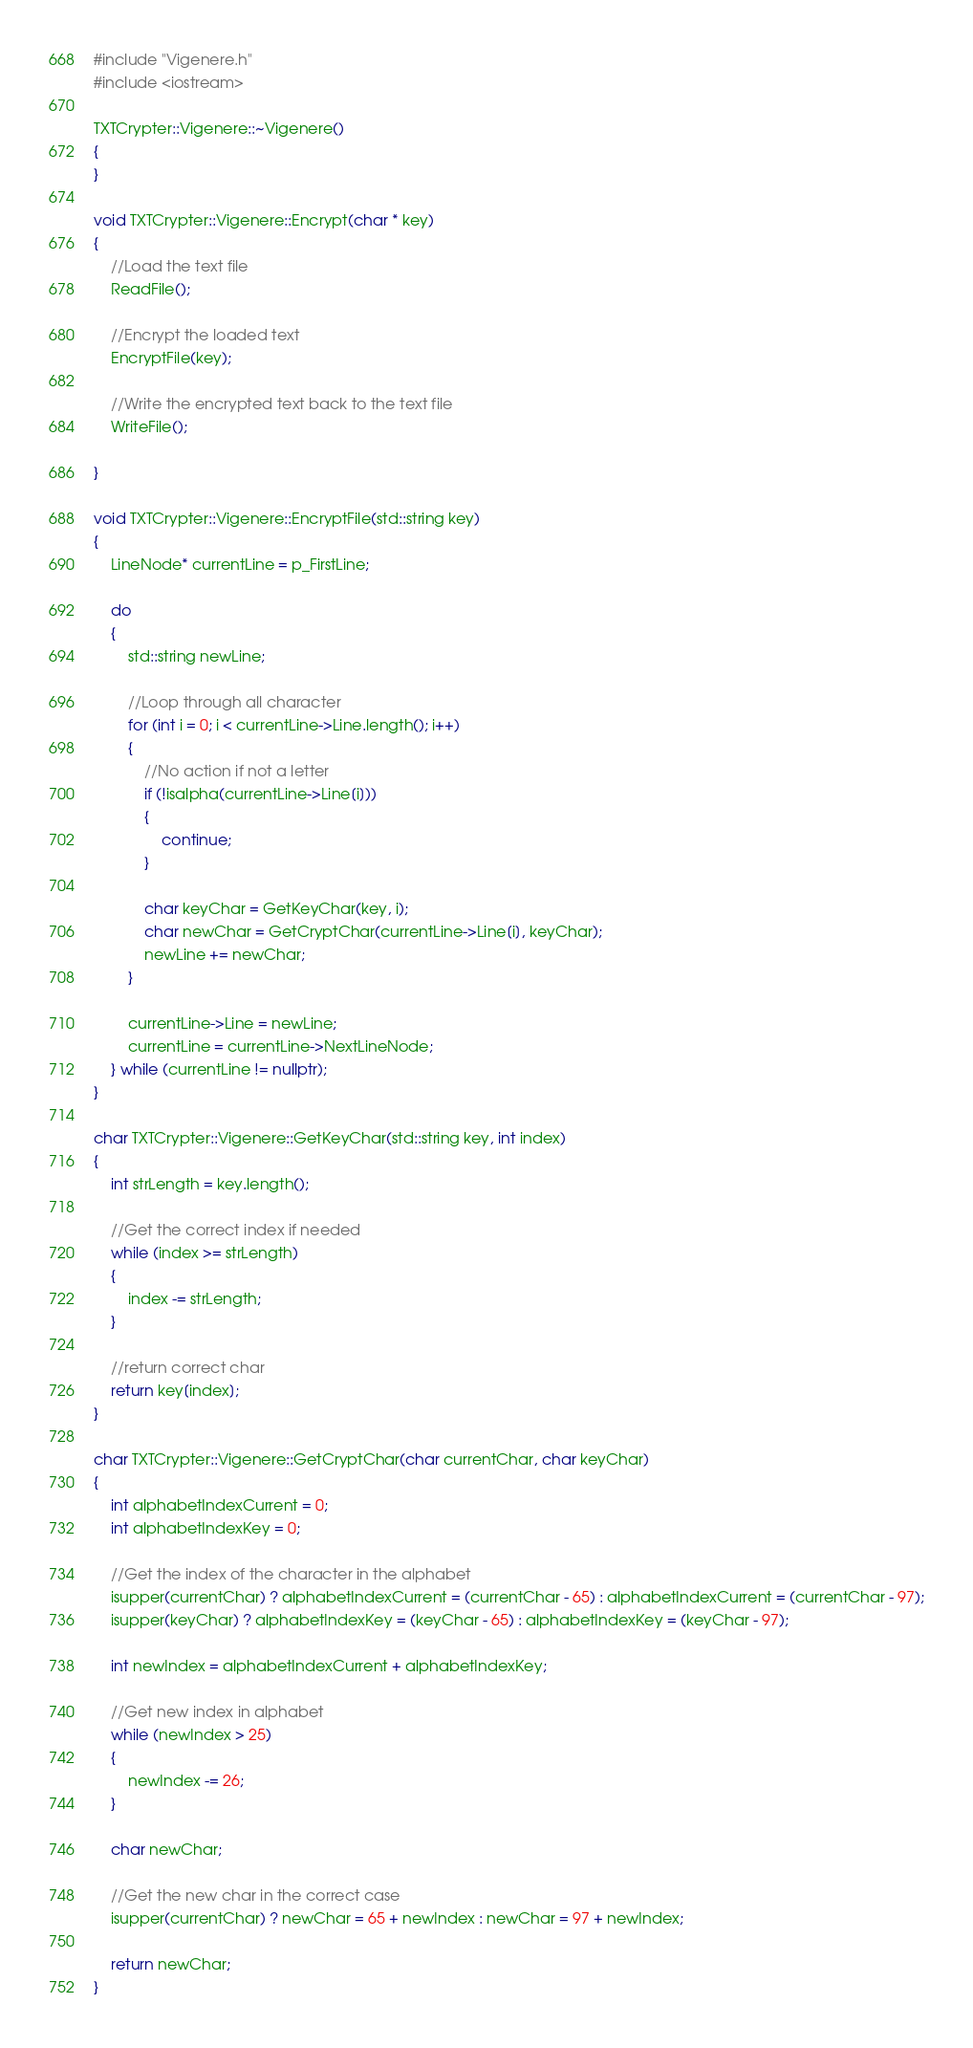Convert code to text. <code><loc_0><loc_0><loc_500><loc_500><_C++_>#include "Vigenere.h"
#include <iostream>

TXTCrypter::Vigenere::~Vigenere()
{
}

void TXTCrypter::Vigenere::Encrypt(char * key)
{
	//Load the text file
	ReadFile();

	//Encrypt the loaded text
	EncryptFile(key);

	//Write the encrypted text back to the text file
	WriteFile();

}

void TXTCrypter::Vigenere::EncryptFile(std::string key)
{
	LineNode* currentLine = p_FirstLine;

	do
	{
		std::string newLine;

		//Loop through all character
		for (int i = 0; i < currentLine->Line.length(); i++)
		{
			//No action if not a letter
			if (!isalpha(currentLine->Line[i]))
			{
				continue;
			}

			char keyChar = GetKeyChar(key, i);
			char newChar = GetCryptChar(currentLine->Line[i], keyChar);
			newLine += newChar;
		}

		currentLine->Line = newLine;
		currentLine = currentLine->NextLineNode;
	} while (currentLine != nullptr);
}

char TXTCrypter::Vigenere::GetKeyChar(std::string key, int index)
{
	int strLength = key.length();

	//Get the correct index if needed
	while (index >= strLength)
	{
		index -= strLength;
	}

	//return correct char
	return key[index];
}

char TXTCrypter::Vigenere::GetCryptChar(char currentChar, char keyChar)
{
	int alphabetIndexCurrent = 0;
	int alphabetIndexKey = 0;

	//Get the index of the character in the alphabet
	isupper(currentChar) ? alphabetIndexCurrent = (currentChar - 65) : alphabetIndexCurrent = (currentChar - 97);
	isupper(keyChar) ? alphabetIndexKey = (keyChar - 65) : alphabetIndexKey = (keyChar - 97);
	
	int newIndex = alphabetIndexCurrent + alphabetIndexKey;

	//Get new index in alphabet
	while (newIndex > 25)
	{
		newIndex -= 26;
	}

	char newChar;

	//Get the new char in the correct case
	isupper(currentChar) ? newChar = 65 + newIndex : newChar = 97 + newIndex;

	return newChar;
}
</code> 